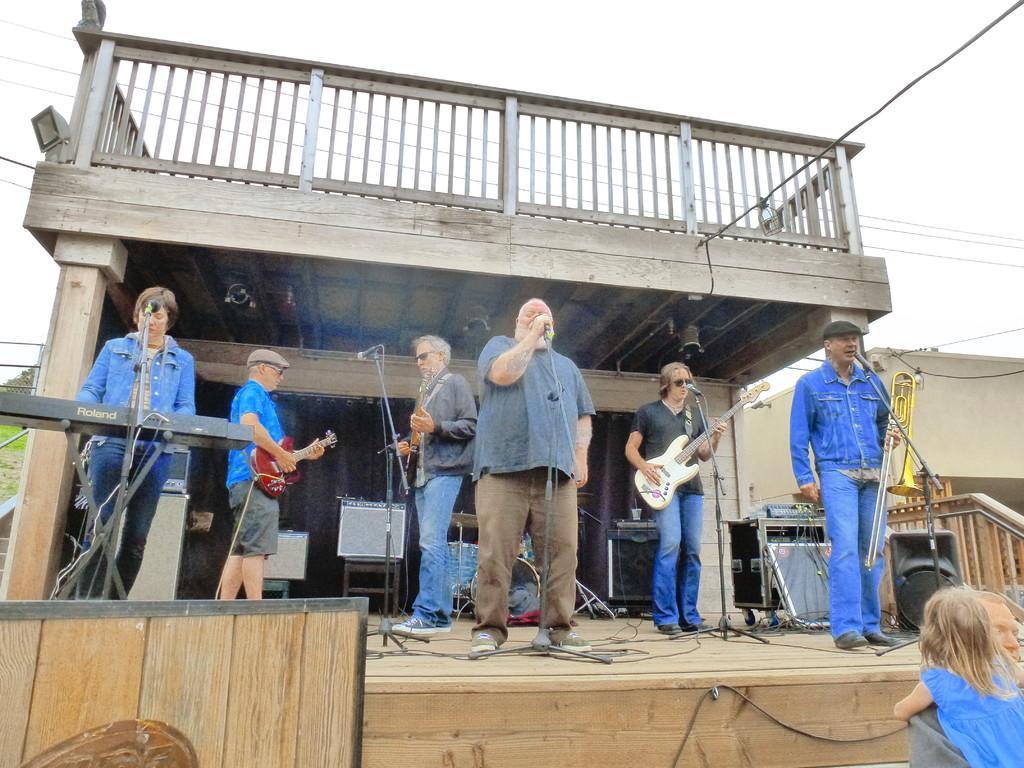Describe this image in one or two sentences. Here are few people standing. One person in the middle is singing a song,three people are playing guitars,one person is playing piano and the other person is holding the musical instrument. These are the mics attached to the mike stand. This is a speaker. I can see electronic devices behind the people. I think this is the cloth hanging. This is the light attached to the rooftop. This is the wooden stage. At the bottom right corner of the image i can see man holding a girl. 